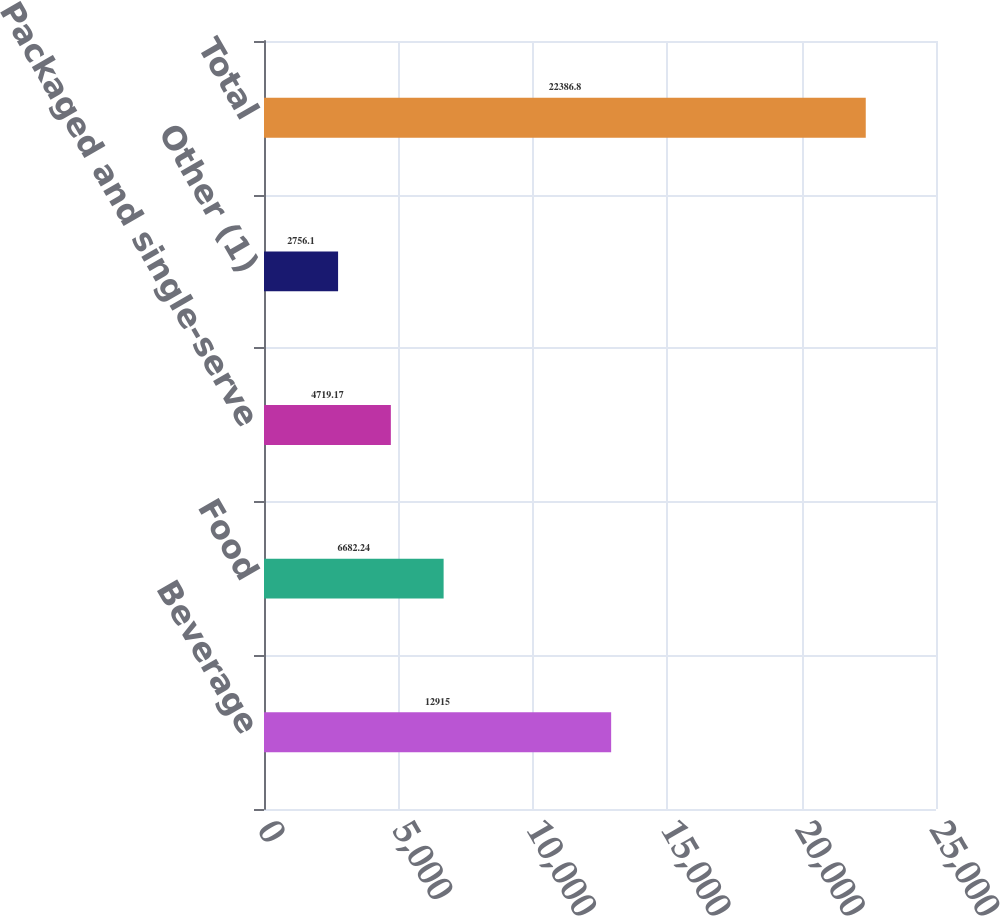Convert chart. <chart><loc_0><loc_0><loc_500><loc_500><bar_chart><fcel>Beverage<fcel>Food<fcel>Packaged and single-serve<fcel>Other (1)<fcel>Total<nl><fcel>12915<fcel>6682.24<fcel>4719.17<fcel>2756.1<fcel>22386.8<nl></chart> 